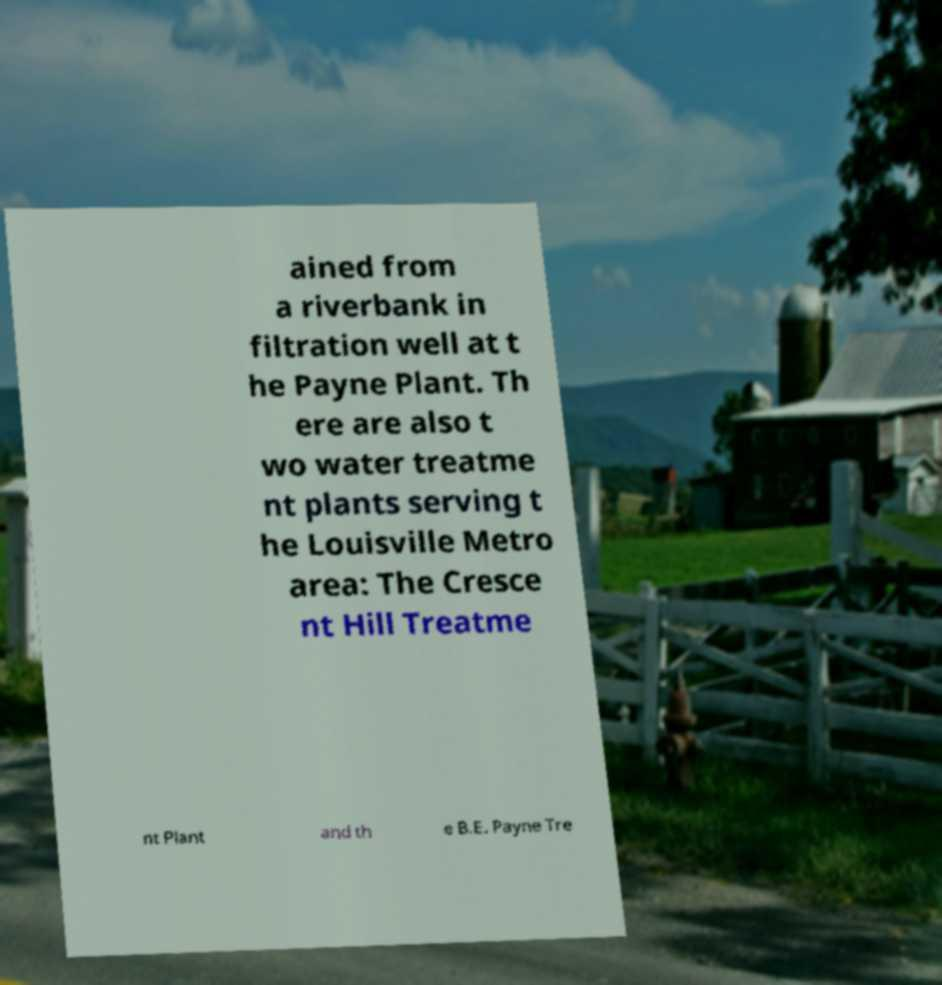I need the written content from this picture converted into text. Can you do that? ained from a riverbank in filtration well at t he Payne Plant. Th ere are also t wo water treatme nt plants serving t he Louisville Metro area: The Cresce nt Hill Treatme nt Plant and th e B.E. Payne Tre 